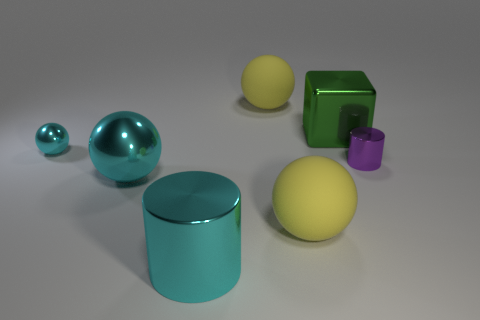What color is the thing that is behind the small cyan object and to the left of the metallic block?
Your response must be concise. Yellow. Do the yellow matte object behind the purple thing and the metal cylinder that is in front of the purple shiny cylinder have the same size?
Give a very brief answer. Yes. How many large metallic spheres have the same color as the small ball?
Make the answer very short. 1. How many tiny objects are either cyan metallic spheres or gray matte balls?
Make the answer very short. 1. Does the big yellow ball behind the small shiny cylinder have the same material as the green block?
Ensure brevity in your answer.  No. There is a cylinder behind the large cyan cylinder; what is its color?
Your response must be concise. Purple. Is there a blue rubber cylinder of the same size as the cyan cylinder?
Make the answer very short. No. Do the purple metallic cylinder and the cylinder to the left of the big green thing have the same size?
Your response must be concise. No. What is the material of the cyan sphere behind the tiny purple object?
Offer a terse response. Metal. Are there the same number of tiny shiny balls right of the green thing and green objects?
Offer a very short reply. No. 